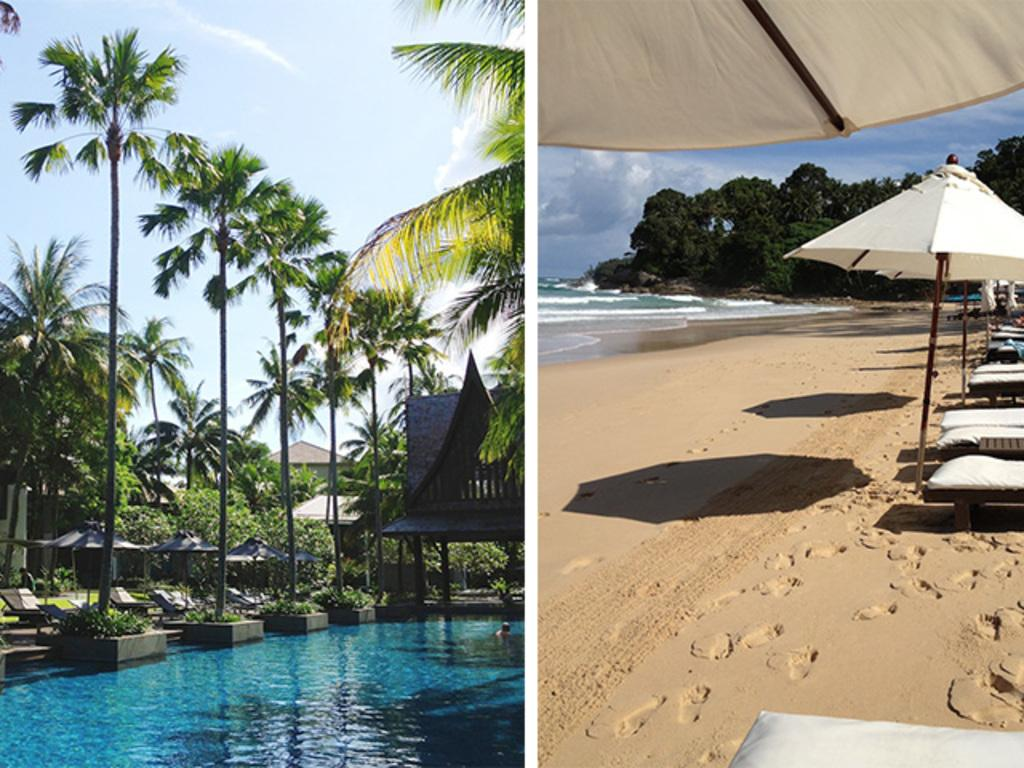What type of artwork is present in the image? There are two collage photos in the image. What subjects are included in the collage photos? The collage photos contain images of trees, clouds, water, and buildings. What type of furniture is visible in the image? There are chairs visible in the image. What is the color of the chairs? The chairs are white in color. What color is present in the image besides the chairs? There are white color shades in the image. Can you see a horse grazing in the image? No, there is no horse present in the image. What type of utensil is being used to eat in the image? There is no utensil visible in the image, as it features collage photos and chairs. 